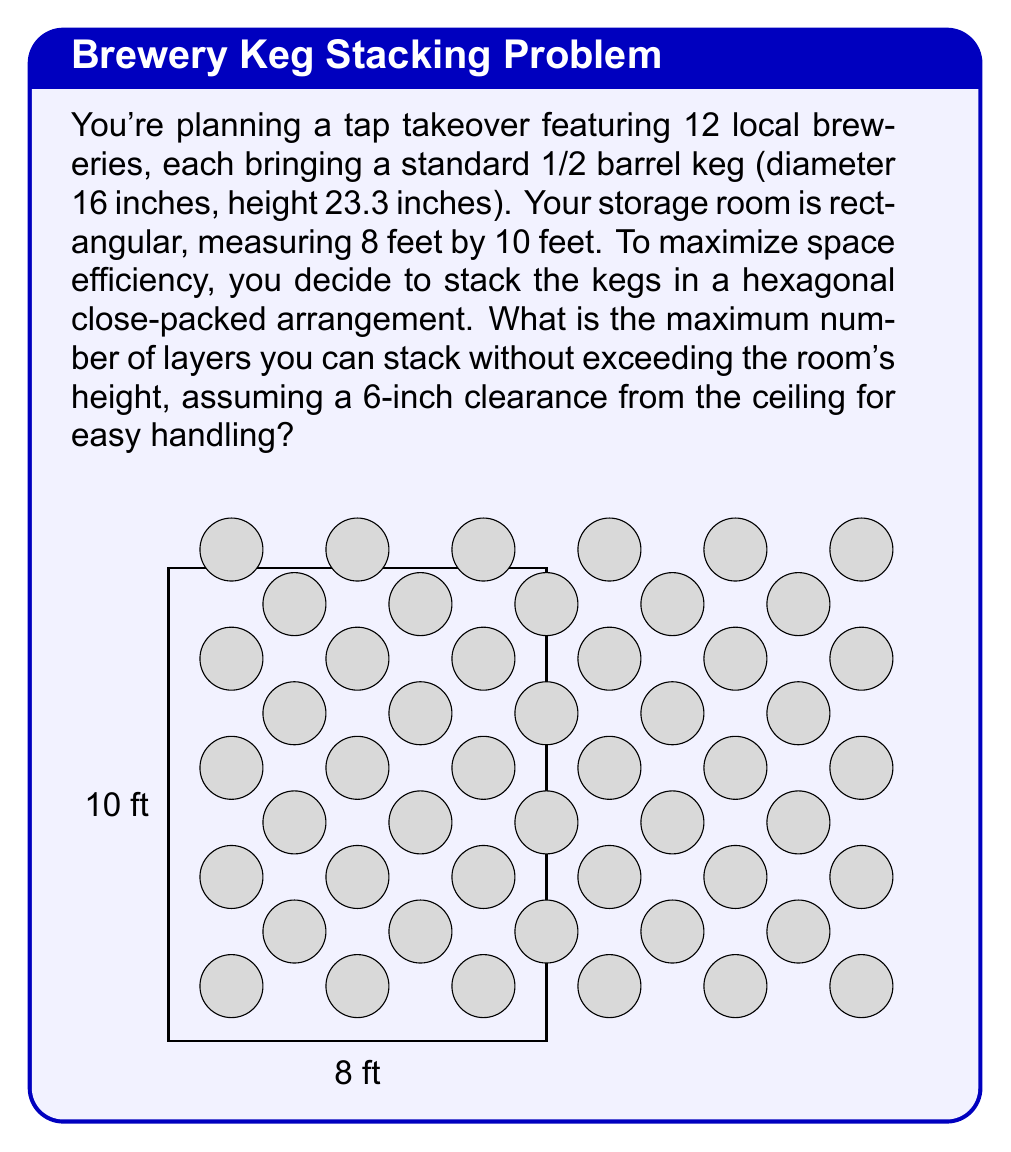What is the answer to this math problem? Let's approach this step-by-step:

1) First, we need to convert all measurements to inches for consistency:
   Room dimensions: 8 ft × 10 ft = 96 in × 120 in
   Room height: 8 ft = 96 in
   Keg height: 23.3 in
   Clearance: 6 in

2) The available height for stacking is:
   $$ 96 \text{ in} - 6 \text{ in} = 90 \text{ in} $$

3) To determine the number of layers, we divide the available height by the keg height:
   $$ \text{Number of layers} = \frac{90 \text{ in}}{23.3 \text{ in}} \approx 3.86 $$

4) Since we can't have a partial layer, we round down to 3 layers.

5) To verify, let's calculate the total height of 3 layers:
   $$ 3 \times 23.3 \text{ in} = 69.9 \text{ in} $$
   This is less than our available 90 inches, so 3 layers will fit.

6) If we try 4 layers:
   $$ 4 \times 23.3 \text{ in} = 93.2 \text{ in} $$
   This exceeds our available 90 inches, confirming that 3 is the maximum.

Therefore, the maximum number of layers that can be stacked is 3.
Answer: 3 layers 